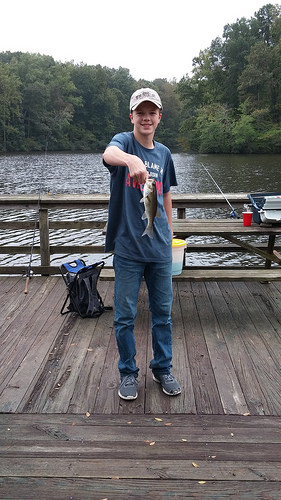<image>
Is there a fish to the right of the boy? No. The fish is not to the right of the boy. The horizontal positioning shows a different relationship. 